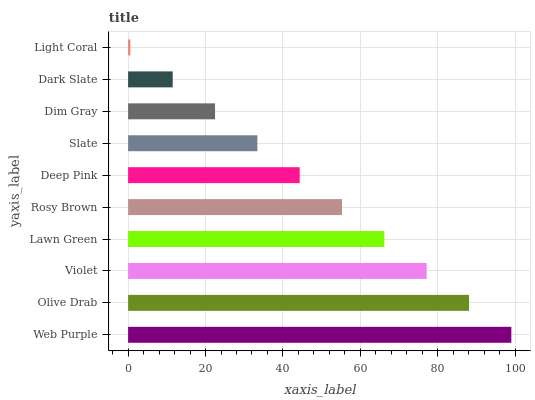Is Light Coral the minimum?
Answer yes or no. Yes. Is Web Purple the maximum?
Answer yes or no. Yes. Is Olive Drab the minimum?
Answer yes or no. No. Is Olive Drab the maximum?
Answer yes or no. No. Is Web Purple greater than Olive Drab?
Answer yes or no. Yes. Is Olive Drab less than Web Purple?
Answer yes or no. Yes. Is Olive Drab greater than Web Purple?
Answer yes or no. No. Is Web Purple less than Olive Drab?
Answer yes or no. No. Is Rosy Brown the high median?
Answer yes or no. Yes. Is Deep Pink the low median?
Answer yes or no. Yes. Is Lawn Green the high median?
Answer yes or no. No. Is Rosy Brown the low median?
Answer yes or no. No. 